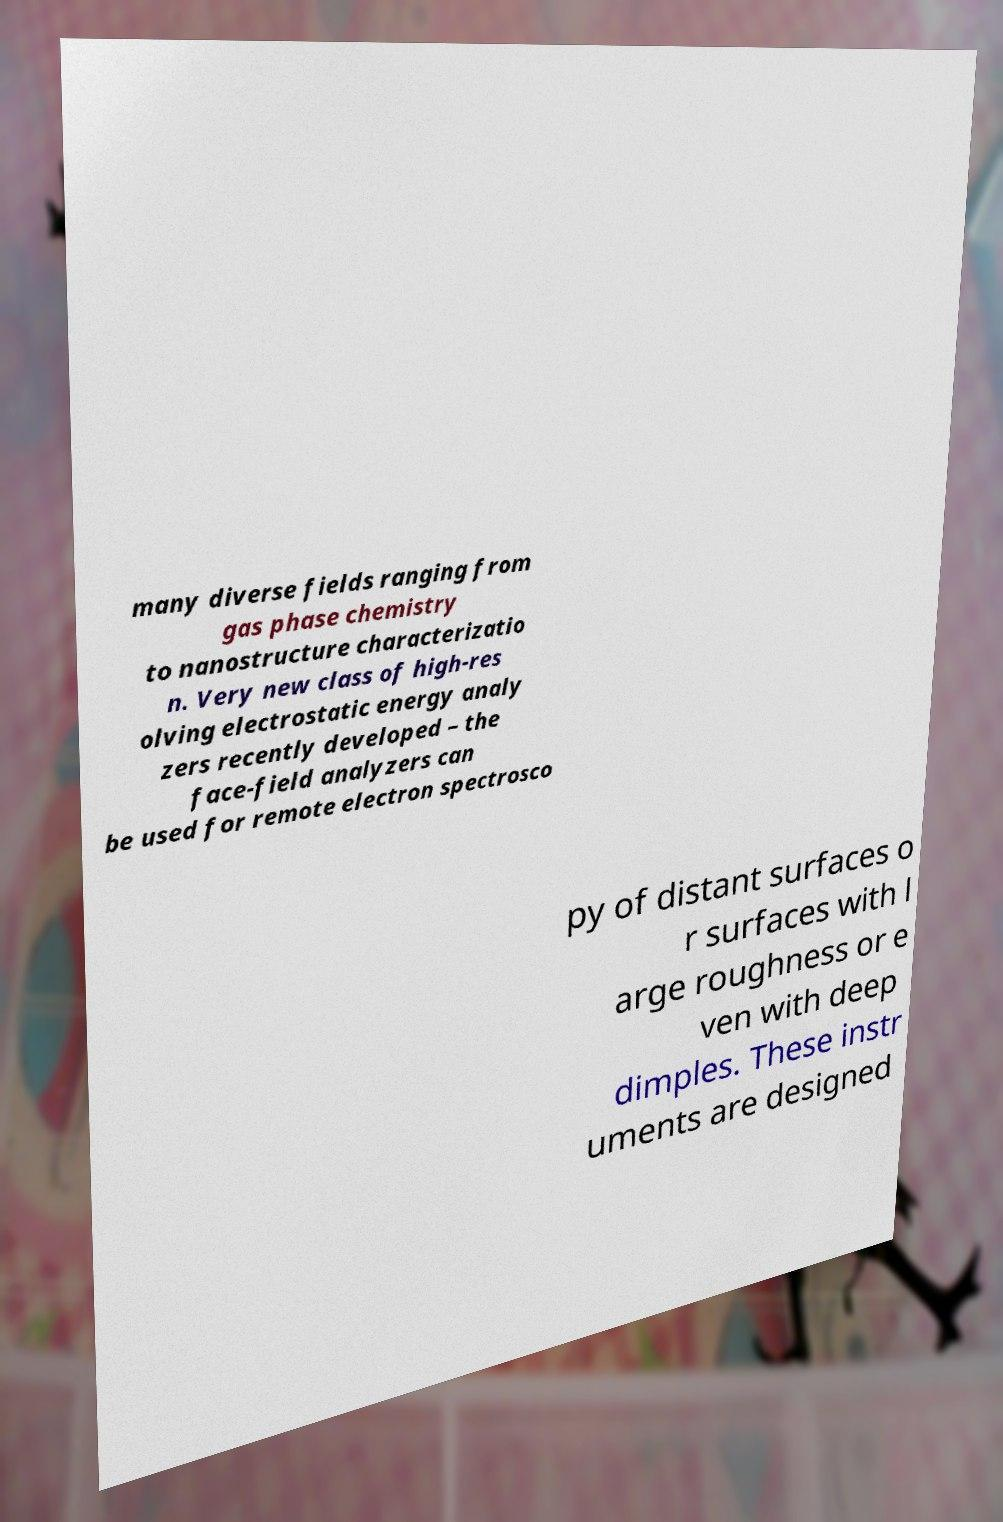Can you read and provide the text displayed in the image?This photo seems to have some interesting text. Can you extract and type it out for me? many diverse fields ranging from gas phase chemistry to nanostructure characterizatio n. Very new class of high-res olving electrostatic energy analy zers recently developed – the face-field analyzers can be used for remote electron spectrosco py of distant surfaces o r surfaces with l arge roughness or e ven with deep dimples. These instr uments are designed 